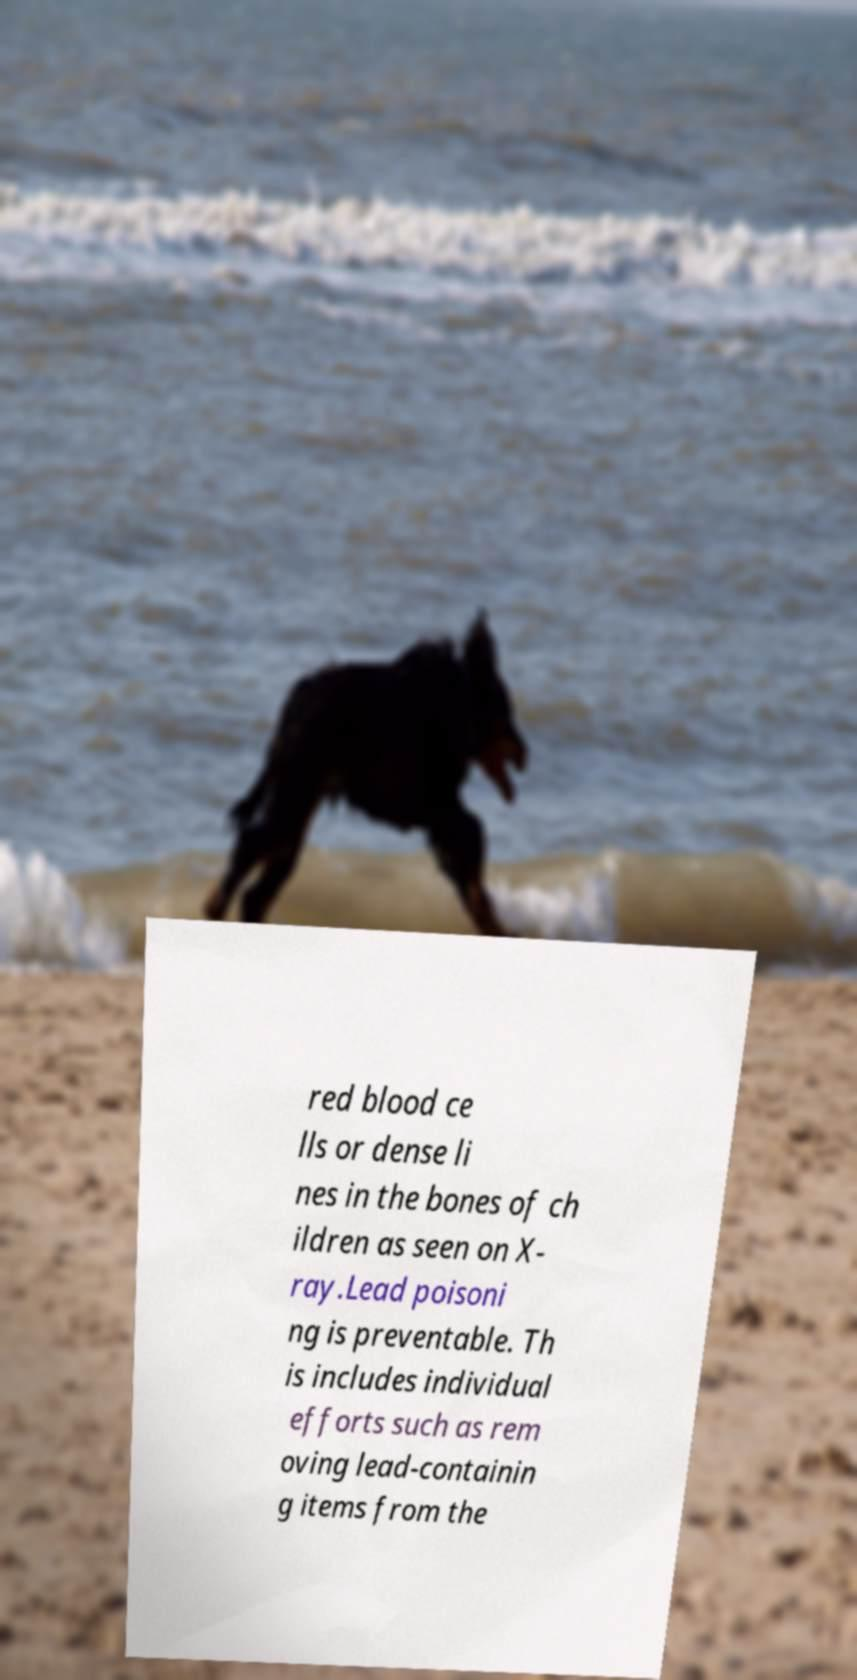There's text embedded in this image that I need extracted. Can you transcribe it verbatim? red blood ce lls or dense li nes in the bones of ch ildren as seen on X- ray.Lead poisoni ng is preventable. Th is includes individual efforts such as rem oving lead-containin g items from the 